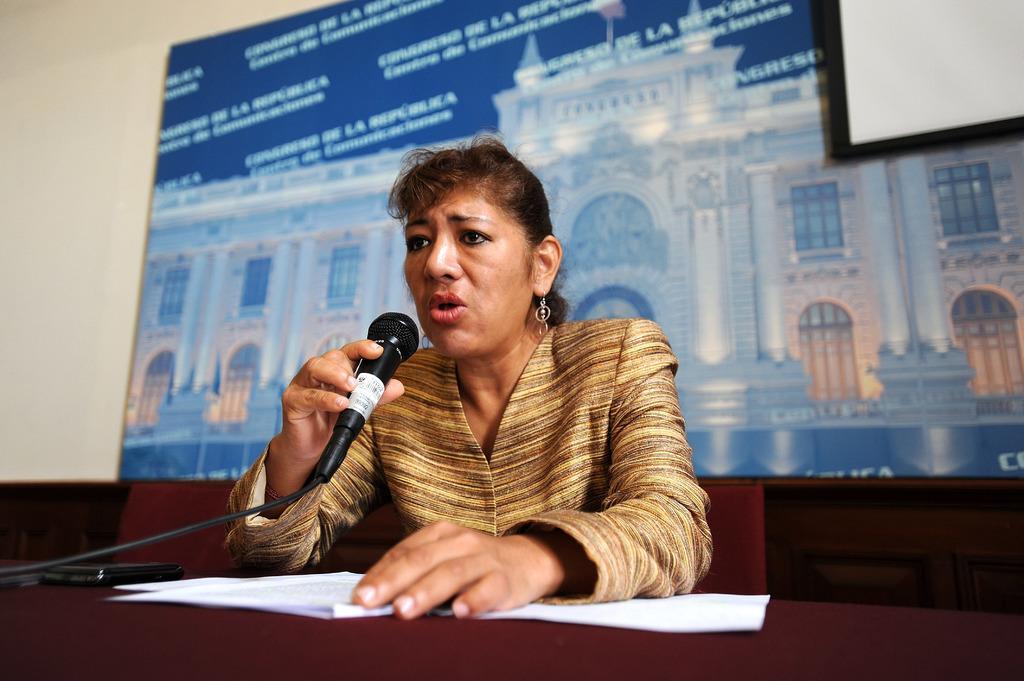Please provide a concise description of this image. In this picture there is a woman sitting on the chair and she is holding the microphone and talking. There are papers and there is a cell phone on the table. At the back there are chairs and there is a board on the wall. On the board there is a text and there is a picture of a building. At the back there is a screen. 